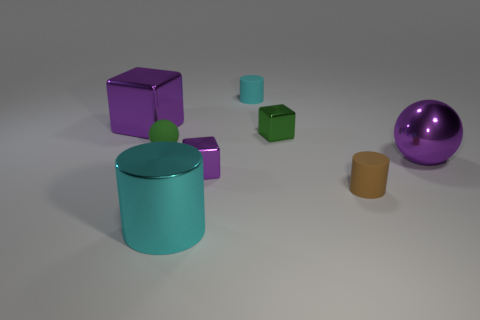Add 2 tiny purple metal cubes. How many objects exist? 10 Subtract all cubes. How many objects are left? 5 Add 8 brown shiny things. How many brown shiny things exist? 8 Subtract 0 cyan cubes. How many objects are left? 8 Subtract all small cyan blocks. Subtract all green metal things. How many objects are left? 7 Add 6 tiny brown matte things. How many tiny brown matte things are left? 7 